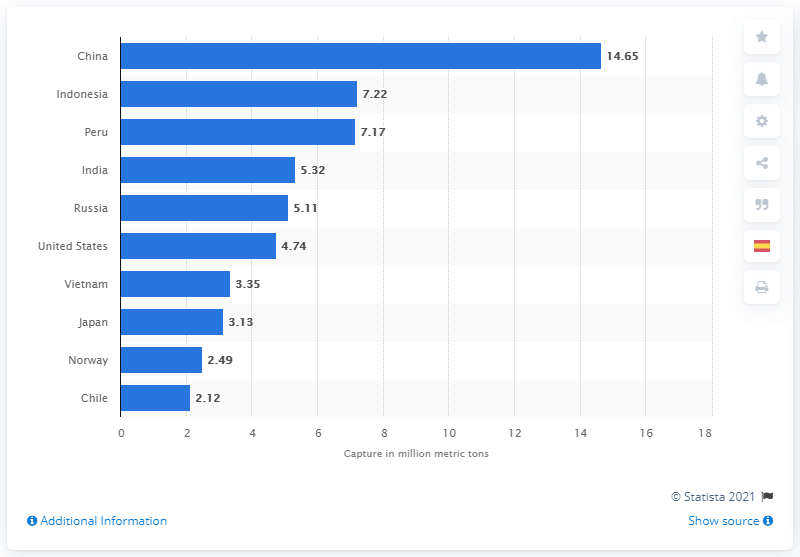Specify some key components in this picture. In 2018, China caught a total of 14.65 million metric tons of fish. 